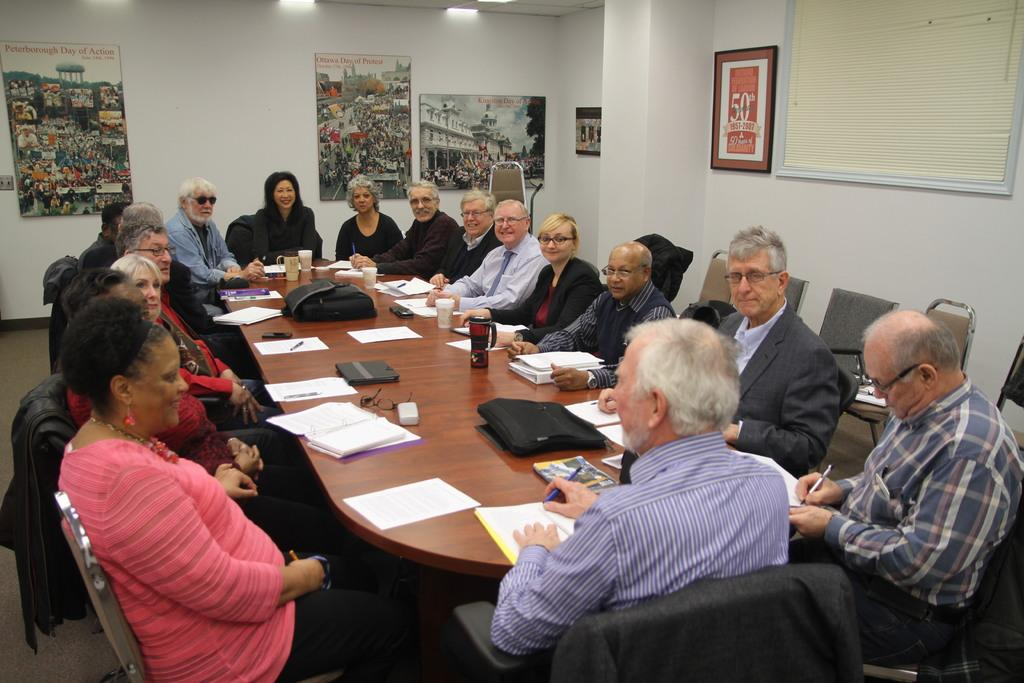How many people are in the image? There is a group of people in the image, but the exact number is not specified. What are the people doing in the image? The people are sitting around a table in the image. Where is the scene taking place? The setting is a meeting hall. What type of pets can be seen playing with the waves in the image? There are no pets or waves present in the image; it features a group of people sitting around a table in a meeting hall. 